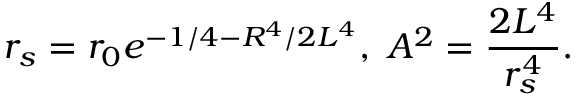<formula> <loc_0><loc_0><loc_500><loc_500>r _ { s } = r _ { 0 } e ^ { - 1 / 4 - R ^ { 4 } / 2 L ^ { 4 } } , \, A ^ { 2 } = { \frac { 2 L ^ { 4 } } { r _ { s } ^ { 4 } } } .</formula> 